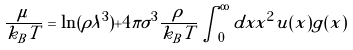Convert formula to latex. <formula><loc_0><loc_0><loc_500><loc_500>\frac { \mu } { k _ { B } T } = \ln ( \rho \lambda ^ { 3 } ) + 4 \pi \sigma ^ { 3 } \frac { \rho } { k _ { B } T } \int _ { 0 } ^ { \infty } d x x ^ { 2 } u ( x ) g ( x )</formula> 